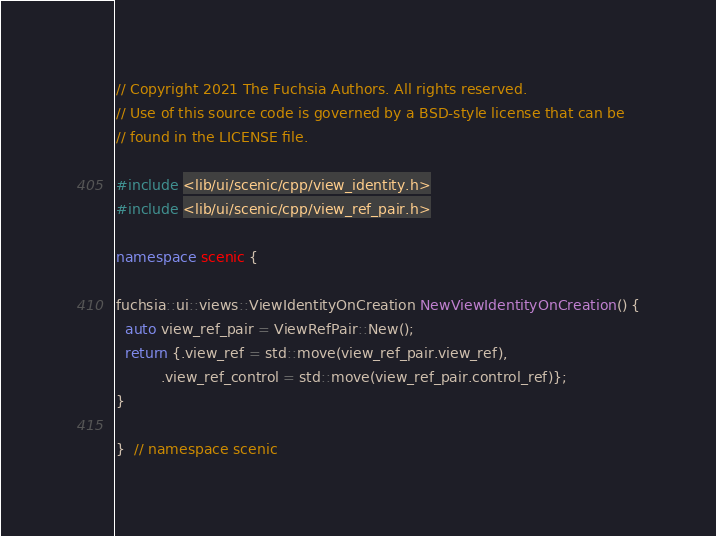<code> <loc_0><loc_0><loc_500><loc_500><_C++_>// Copyright 2021 The Fuchsia Authors. All rights reserved.
// Use of this source code is governed by a BSD-style license that can be
// found in the LICENSE file.

#include <lib/ui/scenic/cpp/view_identity.h>
#include <lib/ui/scenic/cpp/view_ref_pair.h>

namespace scenic {

fuchsia::ui::views::ViewIdentityOnCreation NewViewIdentityOnCreation() {
  auto view_ref_pair = ViewRefPair::New();
  return {.view_ref = std::move(view_ref_pair.view_ref),
          .view_ref_control = std::move(view_ref_pair.control_ref)};
}

}  // namespace scenic
</code> 